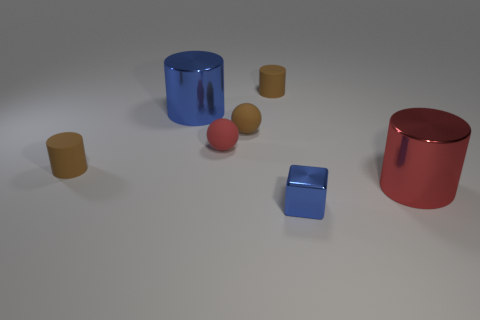What material is the cylinder that is the same color as the small metallic block?
Offer a very short reply. Metal. What number of things are either small blue shiny cubes in front of the red sphere or cylinders on the left side of the red cylinder?
Your answer should be very brief. 4. What is the color of the big shiny object that is in front of the large object that is to the left of the shiny cylinder that is right of the tiny blue metal block?
Keep it short and to the point. Red. How big is the red object on the left side of the blue object that is in front of the small red sphere?
Ensure brevity in your answer.  Small. What material is the small object that is both in front of the small red matte thing and right of the blue cylinder?
Offer a terse response. Metal. There is a shiny block; does it have the same size as the red thing that is to the left of the tiny blue thing?
Give a very brief answer. Yes. Are there any large purple metal objects?
Keep it short and to the point. No. What is the material of the blue object that is the same shape as the large red shiny thing?
Your answer should be compact. Metal. What size is the brown matte cylinder behind the tiny brown cylinder in front of the blue thing left of the tiny block?
Ensure brevity in your answer.  Small. There is a large blue shiny cylinder; are there any matte objects on the left side of it?
Make the answer very short. Yes. 